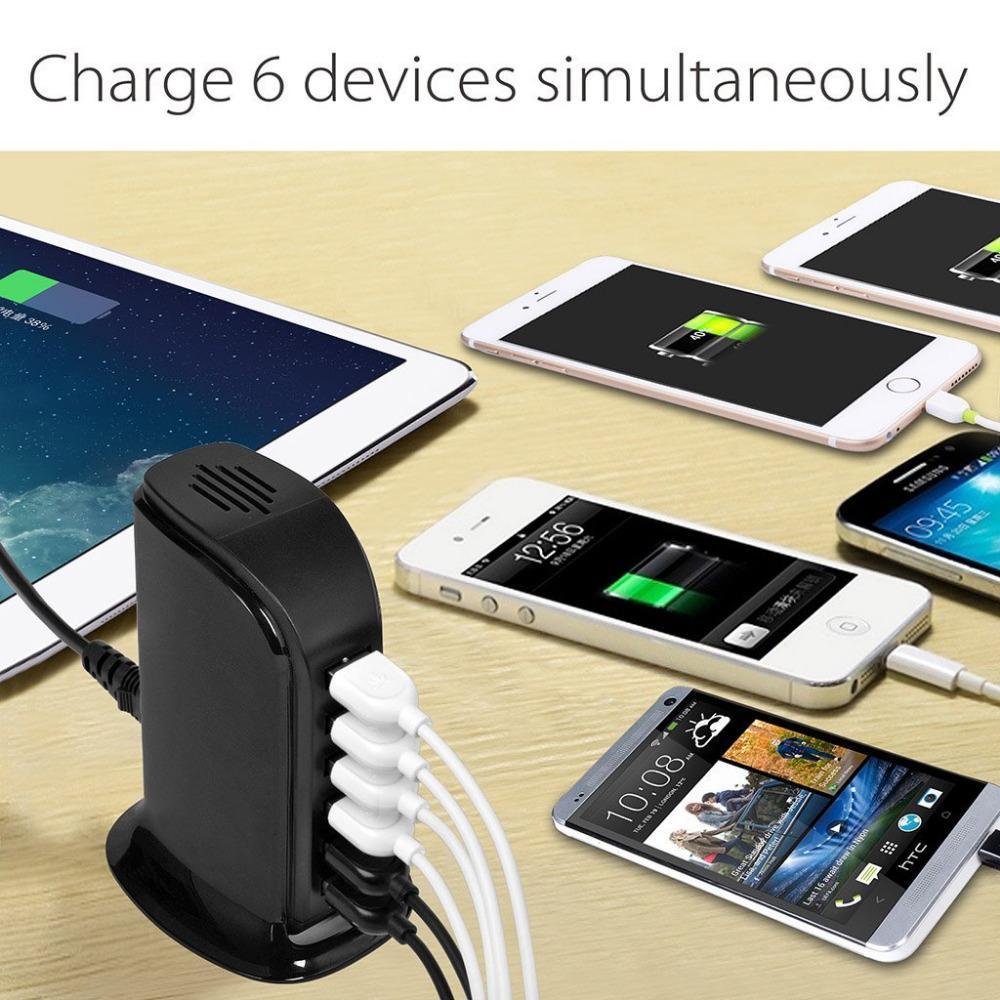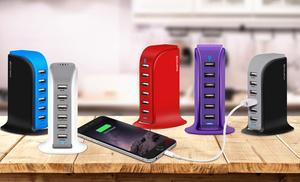The first image is the image on the left, the second image is the image on the right. Considering the images on both sides, is "An image shows an upright charging station with one white cord in the back and several cords all of one color in the front, with multiple screened devices lying flat nearby it on a wood-grain surface." valid? Answer yes or no. No. The first image is the image on the left, the second image is the image on the right. Assess this claim about the two images: "The devices in the left image are plugged into a black colored charging station.". Correct or not? Answer yes or no. Yes. 